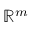<formula> <loc_0><loc_0><loc_500><loc_500>\mathbb { R } ^ { m }</formula> 